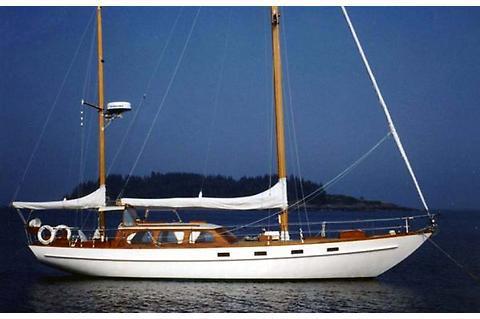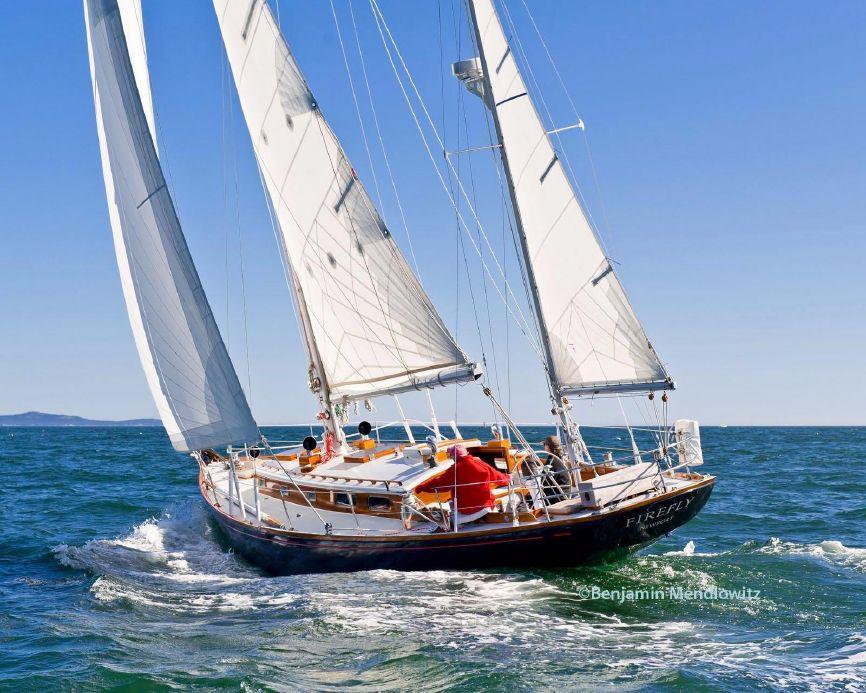The first image is the image on the left, the second image is the image on the right. Evaluate the accuracy of this statement regarding the images: "The left and right image contains a total of three boats.". Is it true? Answer yes or no. No. The first image is the image on the left, the second image is the image on the right. Examine the images to the left and right. Is the description "One boat with a rider in a red jacket creates white spray as it moves through water with unfurled sails, while the other boat is still and has furled sails." accurate? Answer yes or no. Yes. 